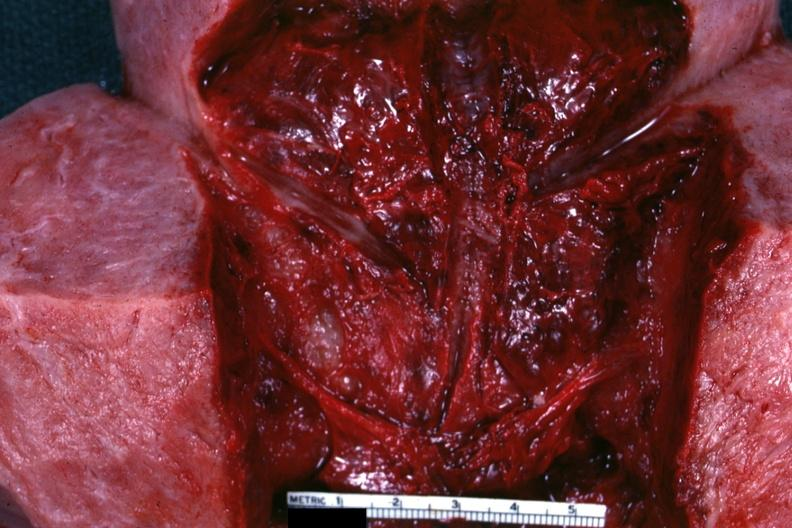what is present?
Answer the question using a single word or phrase. Postpartum 